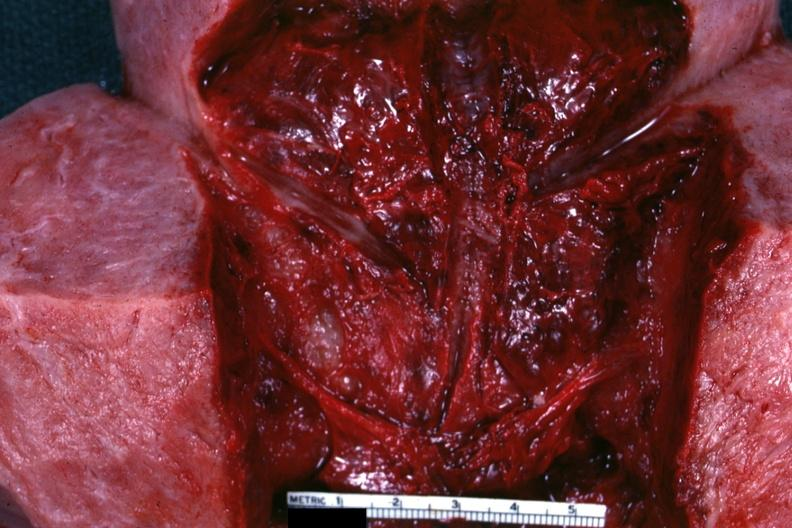what is present?
Answer the question using a single word or phrase. Postpartum 